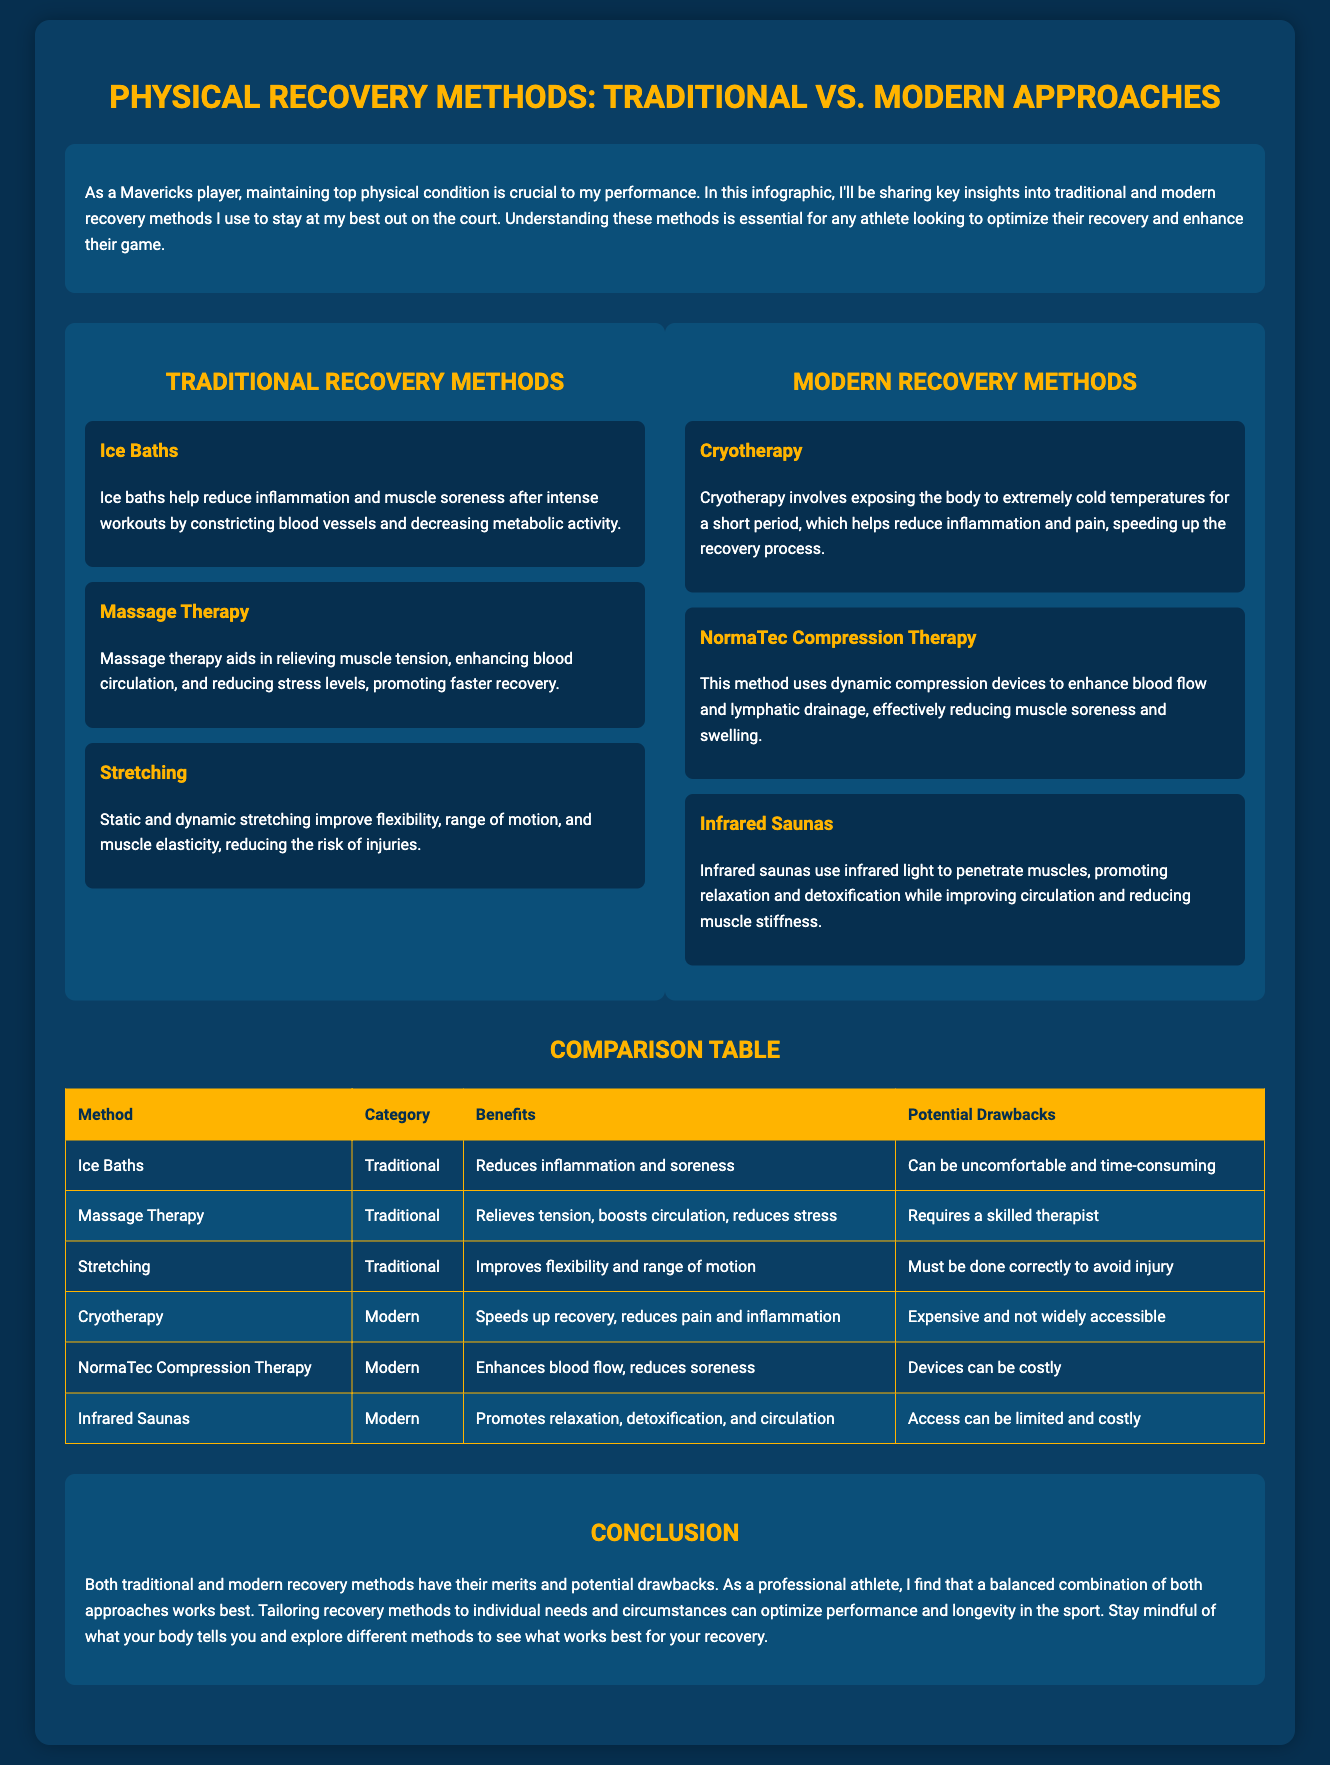What are the three traditional recovery methods listed? The document lists Ice Baths, Massage Therapy, and Stretching as traditional recovery methods.
Answer: Ice Baths, Massage Therapy, Stretching Which recovery method is characterized by extreme cold exposure? This describes Cryotherapy, as mentioned in the modern recovery section.
Answer: Cryotherapy How many benefits are listed for Infrared Saunas? The document states that Infrared Saunas promote relaxation, detoxification, and circulation, which counts as three benefits.
Answer: Three What is a potential drawback of Massage Therapy? The document states that a skilled therapist is required, which can be seen as a limitation.
Answer: Requires a skilled therapist Which recovery method is categorized under both traditional and modern? No recovery method is categorized under both; they are distinctly classified as traditional or modern.
Answer: None What is the primary benefit of NormaTec Compression Therapy? According to the document, the primary benefit is enhancing blood flow and reducing soreness.
Answer: Enhances blood flow, reduces soreness Which traditional method helps improve flexibility? Stretching is explicitly mentioned as the method that improves flexibility.
Answer: Stretching How does the conclusion suggest athletes should approach recovery methods? The conclusion advises that athletes should tailor recovery methods to individual needs and circumstances.
Answer: Tailor recovery methods to individual needs What method is mentioned that uses infrared light? Infrared Saunas are mentioned as using infrared light in the modern recovery methods section.
Answer: Infrared Saunas 